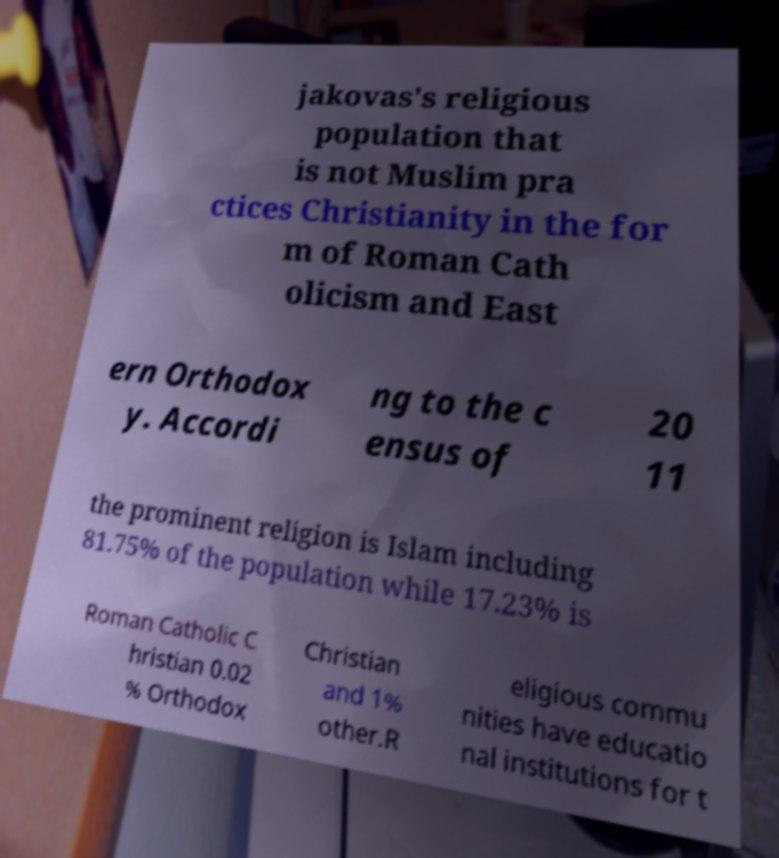Please read and relay the text visible in this image. What does it say? jakovas's religious population that is not Muslim pra ctices Christianity in the for m of Roman Cath olicism and East ern Orthodox y. Accordi ng to the c ensus of 20 11 the prominent religion is Islam including 81.75% of the population while 17.23% is Roman Catholic C hristian 0.02 % Orthodox Christian and 1% other.R eligious commu nities have educatio nal institutions for t 